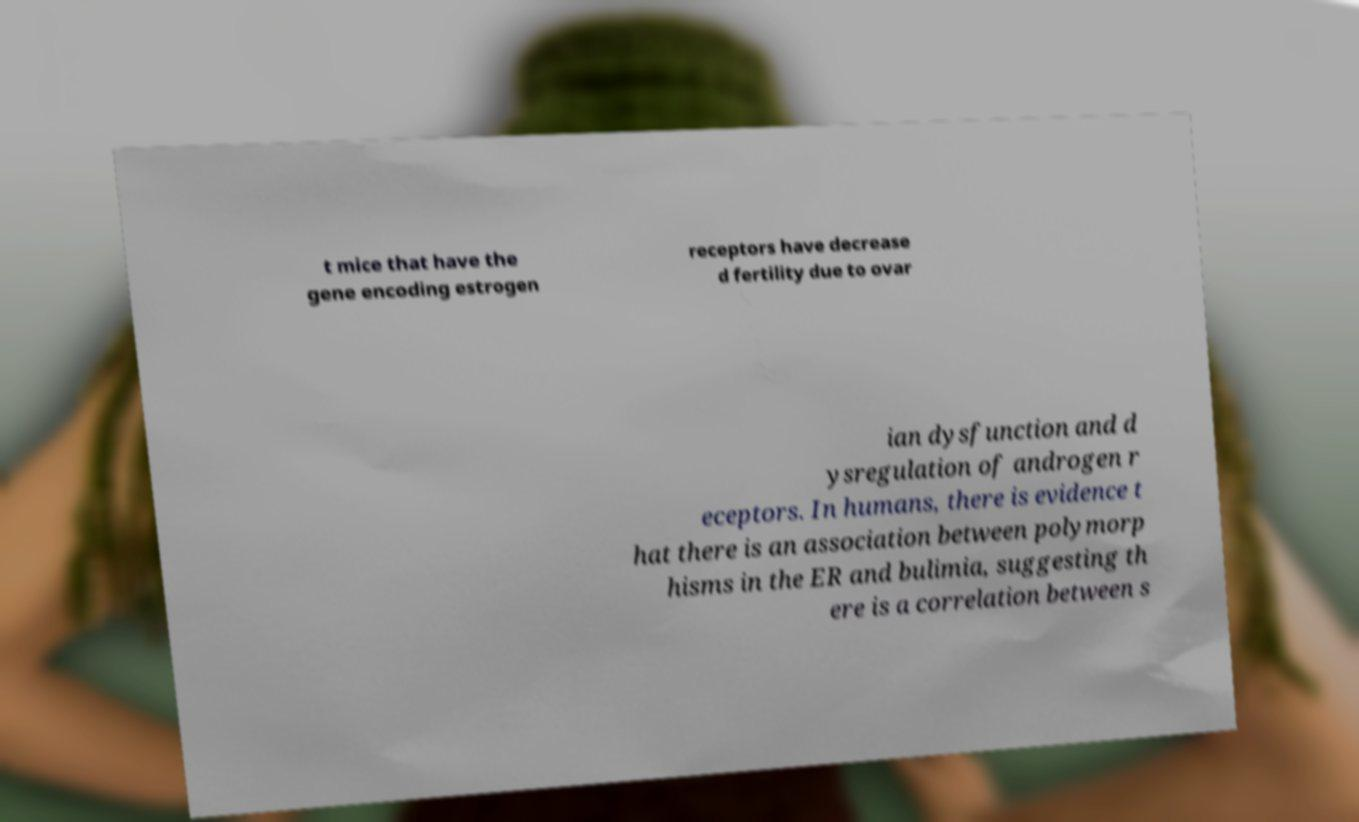Could you assist in decoding the text presented in this image and type it out clearly? t mice that have the gene encoding estrogen receptors have decrease d fertility due to ovar ian dysfunction and d ysregulation of androgen r eceptors. In humans, there is evidence t hat there is an association between polymorp hisms in the ER and bulimia, suggesting th ere is a correlation between s 